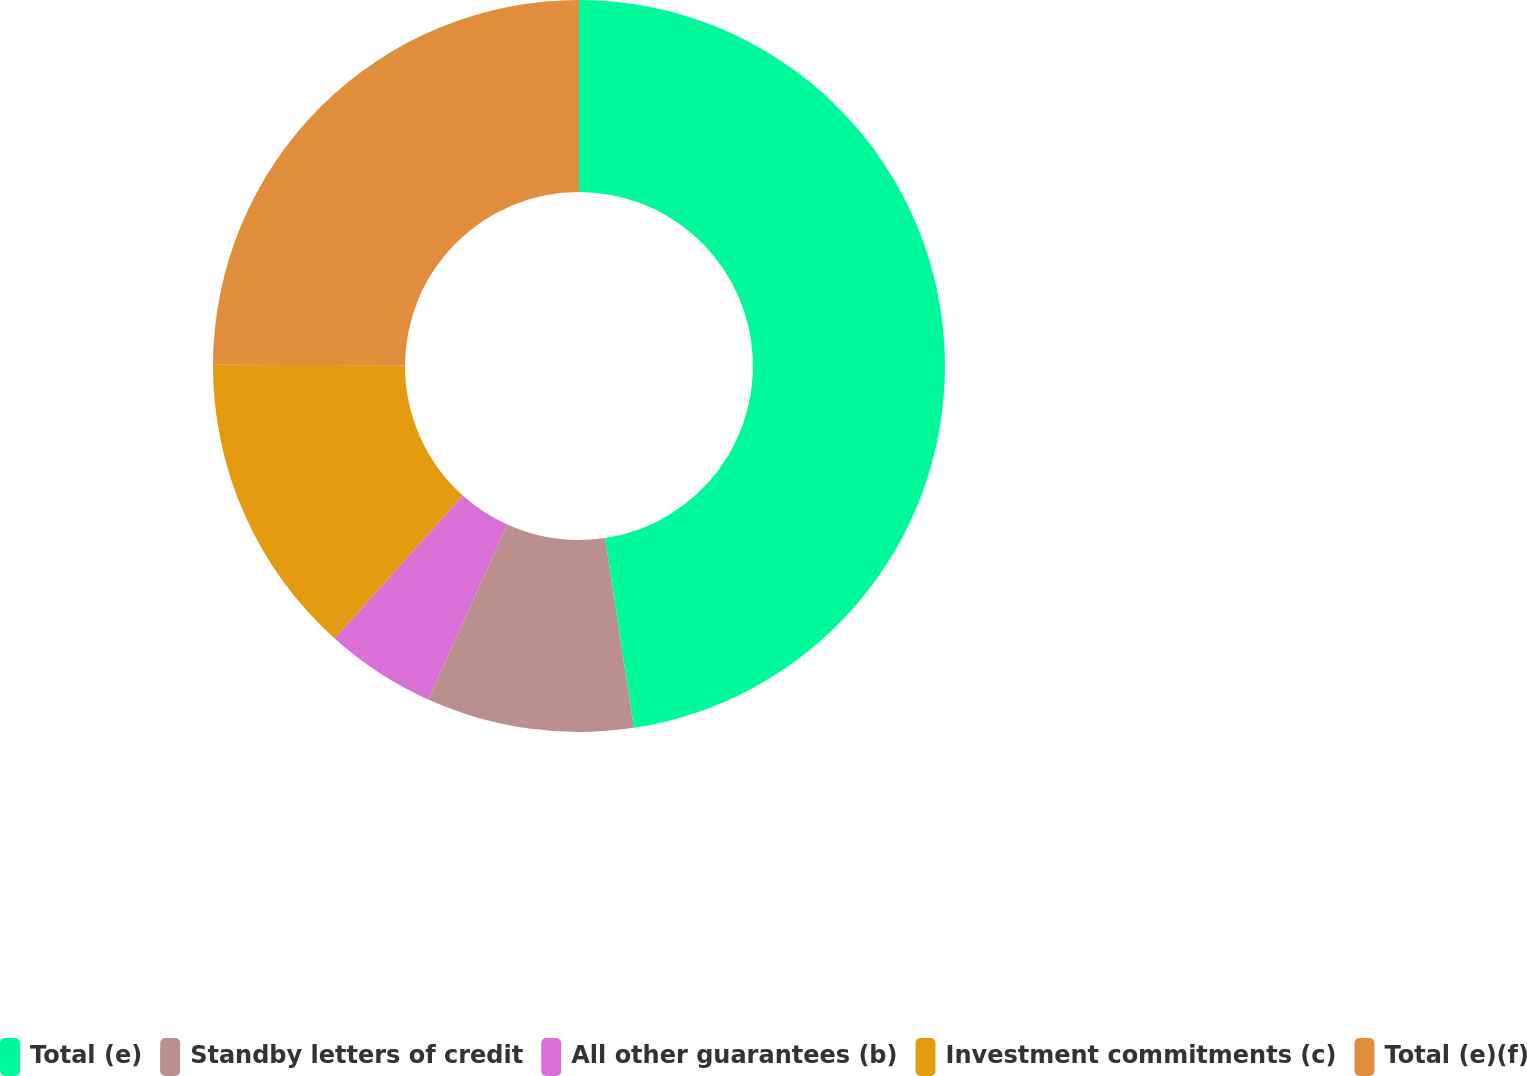Convert chart to OTSL. <chart><loc_0><loc_0><loc_500><loc_500><pie_chart><fcel>Total (e)<fcel>Standby letters of credit<fcel>All other guarantees (b)<fcel>Investment commitments (c)<fcel>Total (e)(f)<nl><fcel>47.6%<fcel>9.15%<fcel>4.88%<fcel>13.42%<fcel>24.94%<nl></chart> 